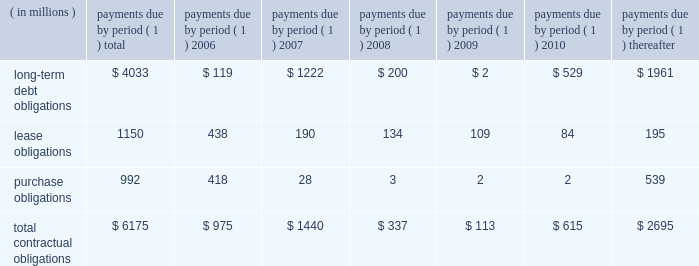57management's discussion and analysis of financial condition and results of operations facility include covenants relating to net interest coverage and total debt-to-book capitalization ratios .
The company was in compliance with the terms of the 3-year credit facility at december 31 , 2005 .
The company has never borrowed under its domestic revolving credit facilities .
Utilization of the non-u.s .
Credit facilities may also be dependent on the company's ability to meet certain conditions at the time a borrowing is requested .
Contractual obligations , guarantees , and other purchase commitments contractual obligations summarized in the table below are the company's obligations and commitments to make future payments under debt obligations ( assuming earliest possible exercise of put rights by holders ) , lease payment obligations , and purchase obligations as of december 31 , 2005 .
Payments due by period ( 1 ) ( in millions ) total 2006 2007 2008 2009 2010 thereafter .
( 1 ) amounts included represent firm , non-cancelable commitments .
Debt obligations : at december 31 , 2005 , the company's long-term debt obligations , including current maturities and unamortized discount and issue costs , totaled $ 4.0 billion , as compared to $ 5.0 billion at december 31 , 2004 .
A table of all outstanding long-term debt securities can be found in note 4 , ""debt and credit facilities'' to the company's consolidated financial statements .
As previously discussed , the decrease in the long- term debt obligations as compared to december 31 , 2004 , was due to the redemptions and repurchases of $ 1.0 billion principal amount of outstanding securities during 2005 .
Also , as previously discussed , the remaining $ 118 million of 7.6% ( 7.6 % ) notes due january 1 , 2007 were reclassified to current maturities of long-term debt .
Lease obligations : the company owns most of its major facilities , but does lease certain office , factory and warehouse space , land , and information technology and other equipment under principally non-cancelable operating leases .
At december 31 , 2005 , future minimum lease obligations , net of minimum sublease rentals , totaled $ 1.2 billion .
Rental expense , net of sublease income , was $ 254 million in 2005 , $ 217 million in 2004 and $ 223 million in 2003 .
Purchase obligations : the company has entered into agreements for the purchase of inventory , license of software , promotional agreements , and research and development agreements which are firm commitments and are not cancelable .
The longest of these agreements extends through 2015 .
Total payments expected to be made under these agreements total $ 992 million .
Commitments under other long-term agreements : the company has entered into certain long-term agreements to purchase software , components , supplies and materials from suppliers .
Most of the agreements extend for periods of one to three years ( three to five years for software ) .
However , generally these agreements do not obligate the company to make any purchases , and many permit the company to terminate the agreement with advance notice ( usually ranging from 60 to 180 days ) .
If the company were to terminate these agreements , it generally would be liable for certain termination charges , typically based on work performed and supplier on-hand inventory and raw materials attributable to canceled orders .
The company's liability would only arise in the event it terminates the agreements for reasons other than ""cause.'' in 2003 , the company entered into outsourcing contracts for certain corporate functions , such as benefit administration and information technology related services .
These contracts generally extend for 10 years and are expected to expire in 2013 .
The total payments under these contracts are approximately $ 3 billion over 10 years ; however , these contracts can be terminated .
Termination would result in a penalty substantially less than the annual contract payments .
The company would also be required to find another source for these services , including the possibility of performing them in-house .
As is customary in bidding for and completing network infrastructure projects and pursuant to a practice the company has followed for many years , the company has a number of performance/bid bonds and standby letters of credit outstanding , primarily relating to projects of government and enterprise mobility solutions segment and the networks segment .
These instruments normally have maturities of up to three years and are standard in the .
In 2007 what was the percent of the total long-term debt obligations? 
Computations: (1222 / 4033)
Answer: 0.303. 